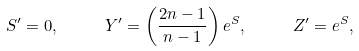Convert formula to latex. <formula><loc_0><loc_0><loc_500><loc_500>S ^ { \prime } = 0 , \quad \ Y ^ { \prime } = \left ( \frac { 2 n - 1 } { n - 1 } \right ) e ^ { S } , \quad \ Z ^ { \prime } = e ^ { S } ,</formula> 